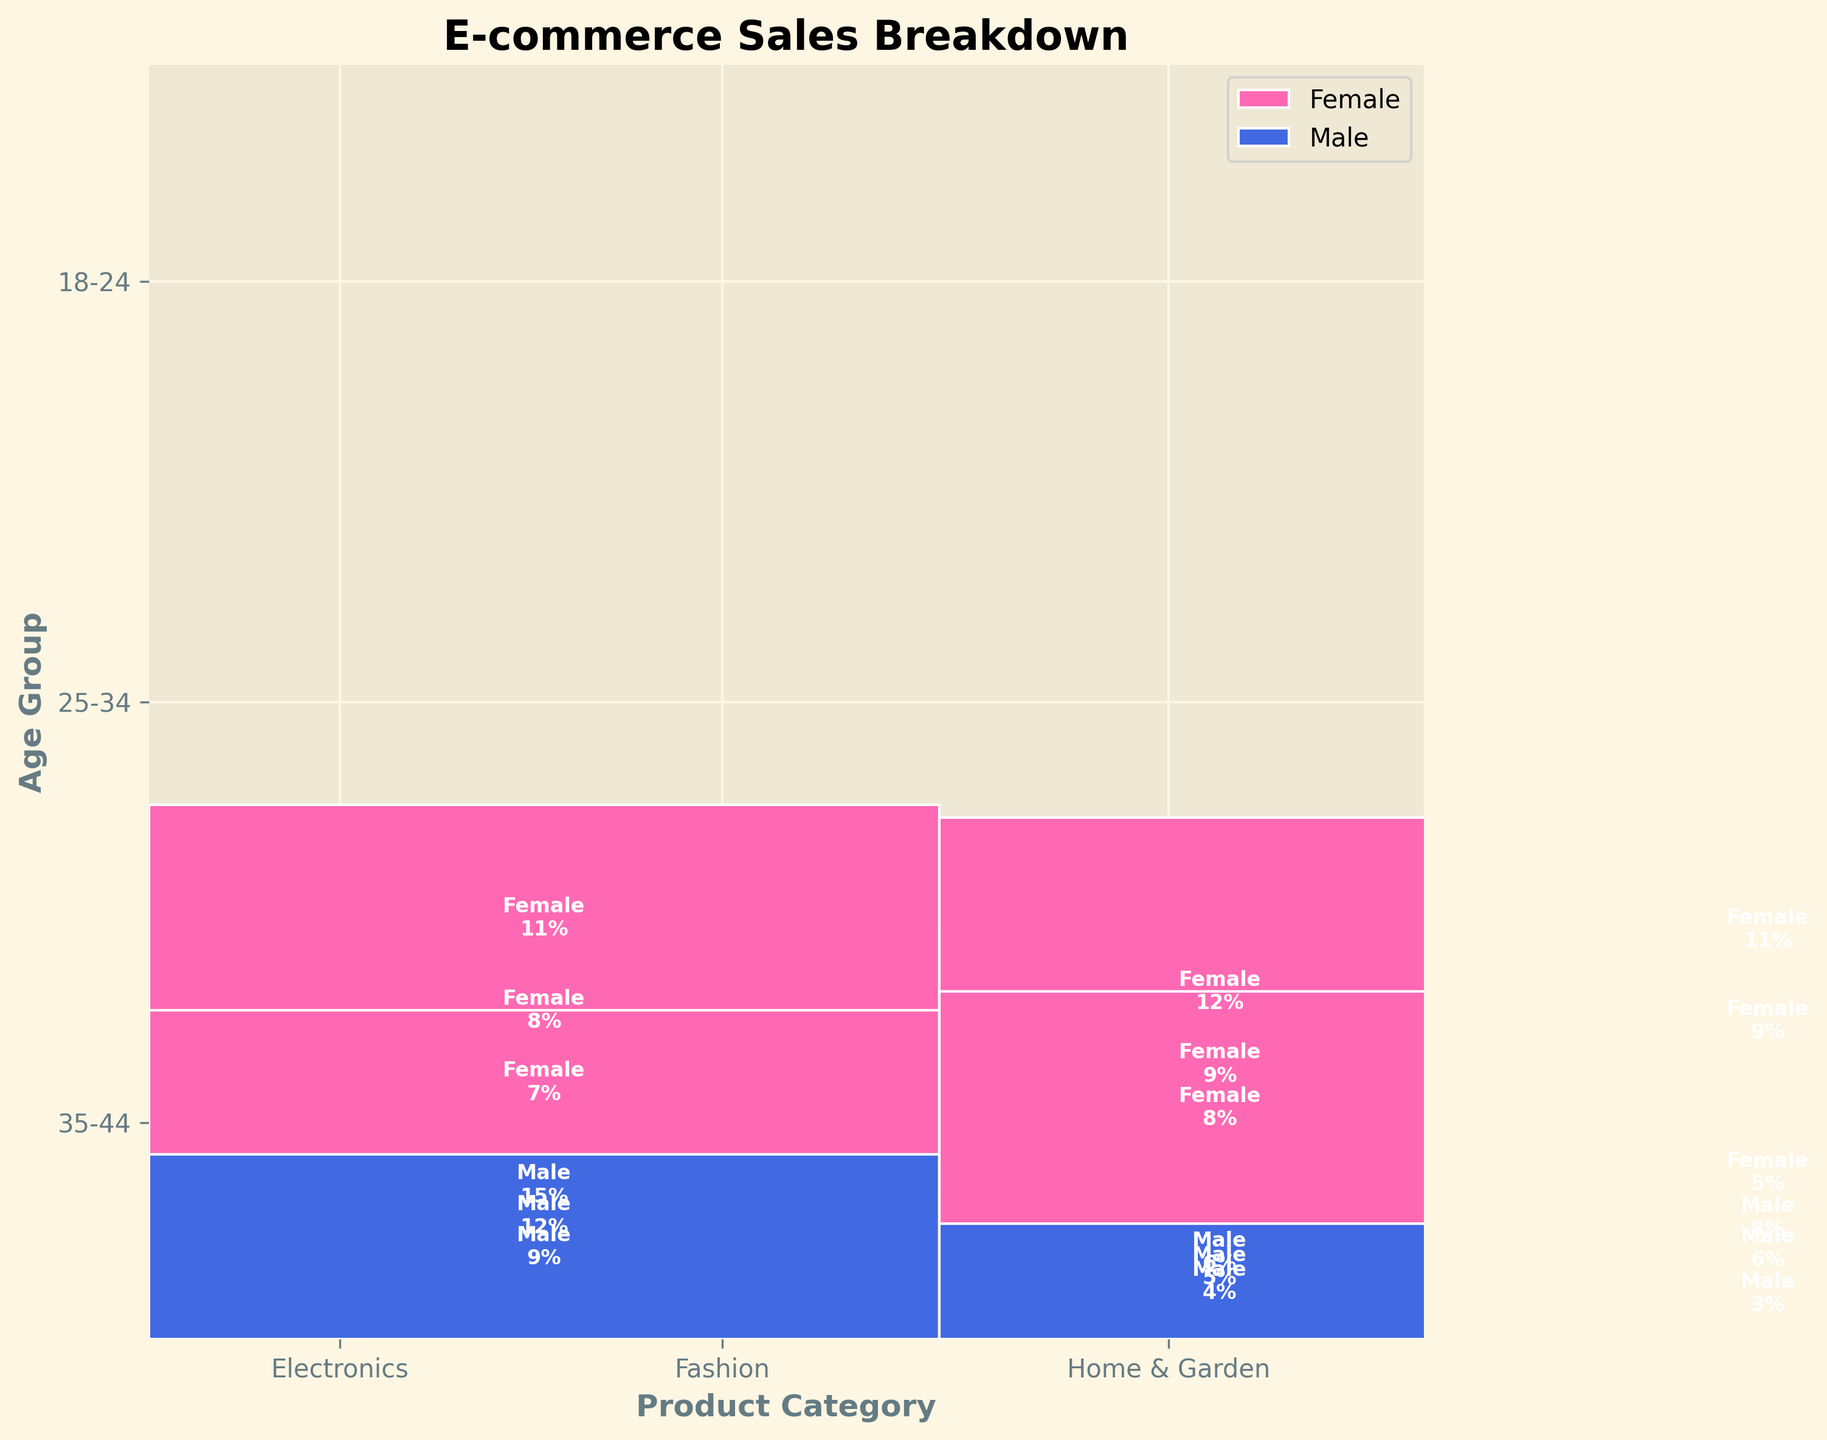What is the title of the plot? The title of the plot is displayed at the top and it states the main purpose or summary of the visual information.
Answer: E-commerce Sales Breakdown What do the different colors in the plot represent? The colors indicate the gender of the customers, where pink represents females and blue represents males.
Answer: Gender Which product category has the highest sales percentage among 25-34-year-old females? Looking at the rectangles for 25-34-year-old females across all product categories, we see that the rectangle for Home & Garden is the largest.
Answer: Home & Garden How many age groups are represented in the plot? The y-axis labels list the different age groups represented, and there are three: 18-24, 25-34, and 35-44.
Answer: 3 What is the sales percentage of Electronics for the 18-24 age group? By adding the sales percentages for males and females in the 18-24 age group within the Electronics category, we get 12% + 8%.
Answer: 20% Which age group is shown to have the highest proportion of Home & Garden sales among males? Comparing the rectangles for males across all age groups in the Home & Garden category, the 35-44 age group has the largest area.
Answer: 35-44 Do males or females contribute more to the Fashion sales percentage in the 25-34 age group? Comparing the rectangles for males and females within the 25-34 age group in the Fashion category, the female rectangle is larger than the male one.
Answer: Females What is the combined sales percentage for males aged 25-34 across all product categories? Adding up the sales percentages for males aged 25-34 in each category: 15% (Electronics) + 6% (Fashion) + 6% (Home & Garden), the total is 27%.
Answer: 27% Which product category has the smallest sales percentage for 18-24-year-old males? Comparing the sales percentages for 18-24-year-old males across product categories, Home & Garden has the smallest percentage with 3%.
Answer: Home & Garden In the Electronics category, which gender and age group combination has the lowest sales percentage? By examining the rectangles within the Electronics category, the female group aged 35-44 has the smallest rectangle, representing 7%.
Answer: Female, 35-44 